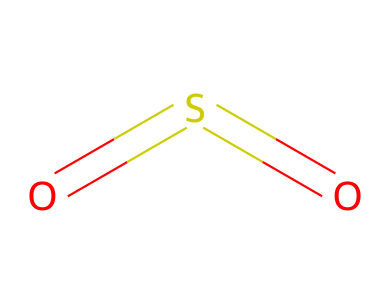What is the molecular formula for sulfur dioxide? The SMILES representation shows the atoms involved: there are one sulfur (S) and two oxygen (O) atoms. Therefore, the molecular formula is constructed by listing these elements along with their respective counts.
Answer: SO2 How many total atoms are in sulfur dioxide? From the molecular formula SO2, we see there is one sulfur atom and two oxygen atoms. Adding them together gives a total of three atoms.
Answer: 3 What type of bonds are present in sulfur dioxide? The SMILES representation indicates the sulfur atom is double-bonded to both oxygen atoms (which is represented by the '=' signs). This means sulfur dioxide contains two double bonds.
Answer: double bonds Which atom is the central atom in sulfur dioxide? In the structure depicted in the SMILES notation, the sulfur atom is bonded to two oxygen atoms, which indicates that sulfur is the central atom in the molecular structure.
Answer: sulfur What is the state of sulfur dioxide at room temperature? Sulfur dioxide is a gas at room temperature. This is a characteristic of many small molecular compounds and is supported by its lightweight molecular structure.
Answer: gas How does the presence of sulfur dioxide affect respiratory health? Sulfur dioxide is known to be an air pollutant that can irritate the respiratory system, leading to issues such as asthma and other respiratory diseases. This is derived from its chemical nature as a pollutant.
Answer: irritant 